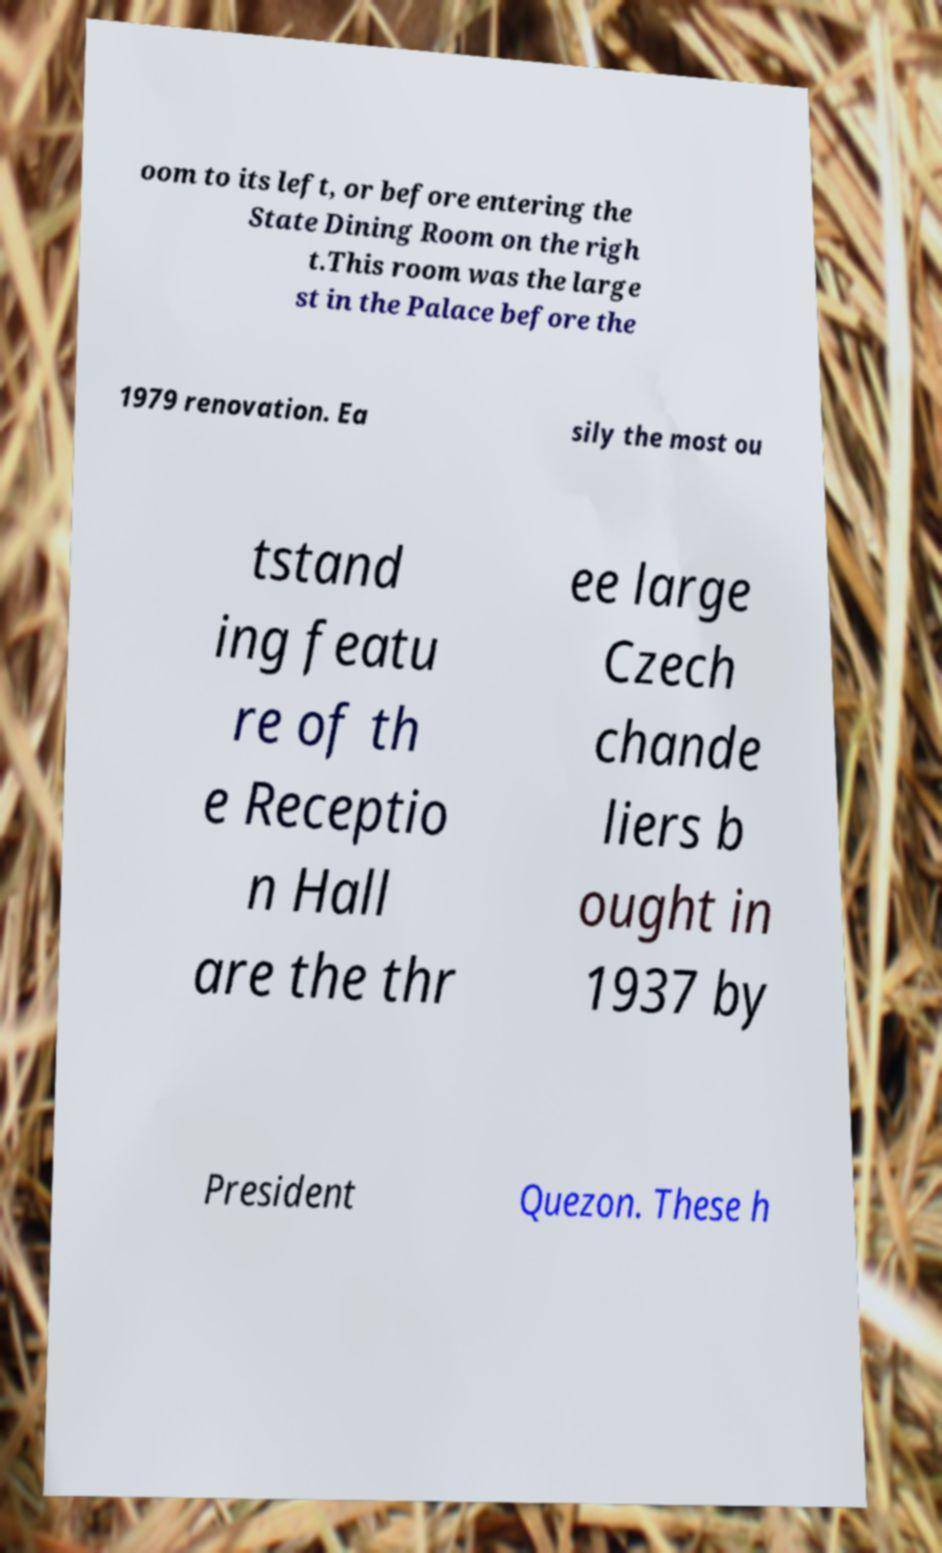Please identify and transcribe the text found in this image. oom to its left, or before entering the State Dining Room on the righ t.This room was the large st in the Palace before the 1979 renovation. Ea sily the most ou tstand ing featu re of th e Receptio n Hall are the thr ee large Czech chande liers b ought in 1937 by President Quezon. These h 